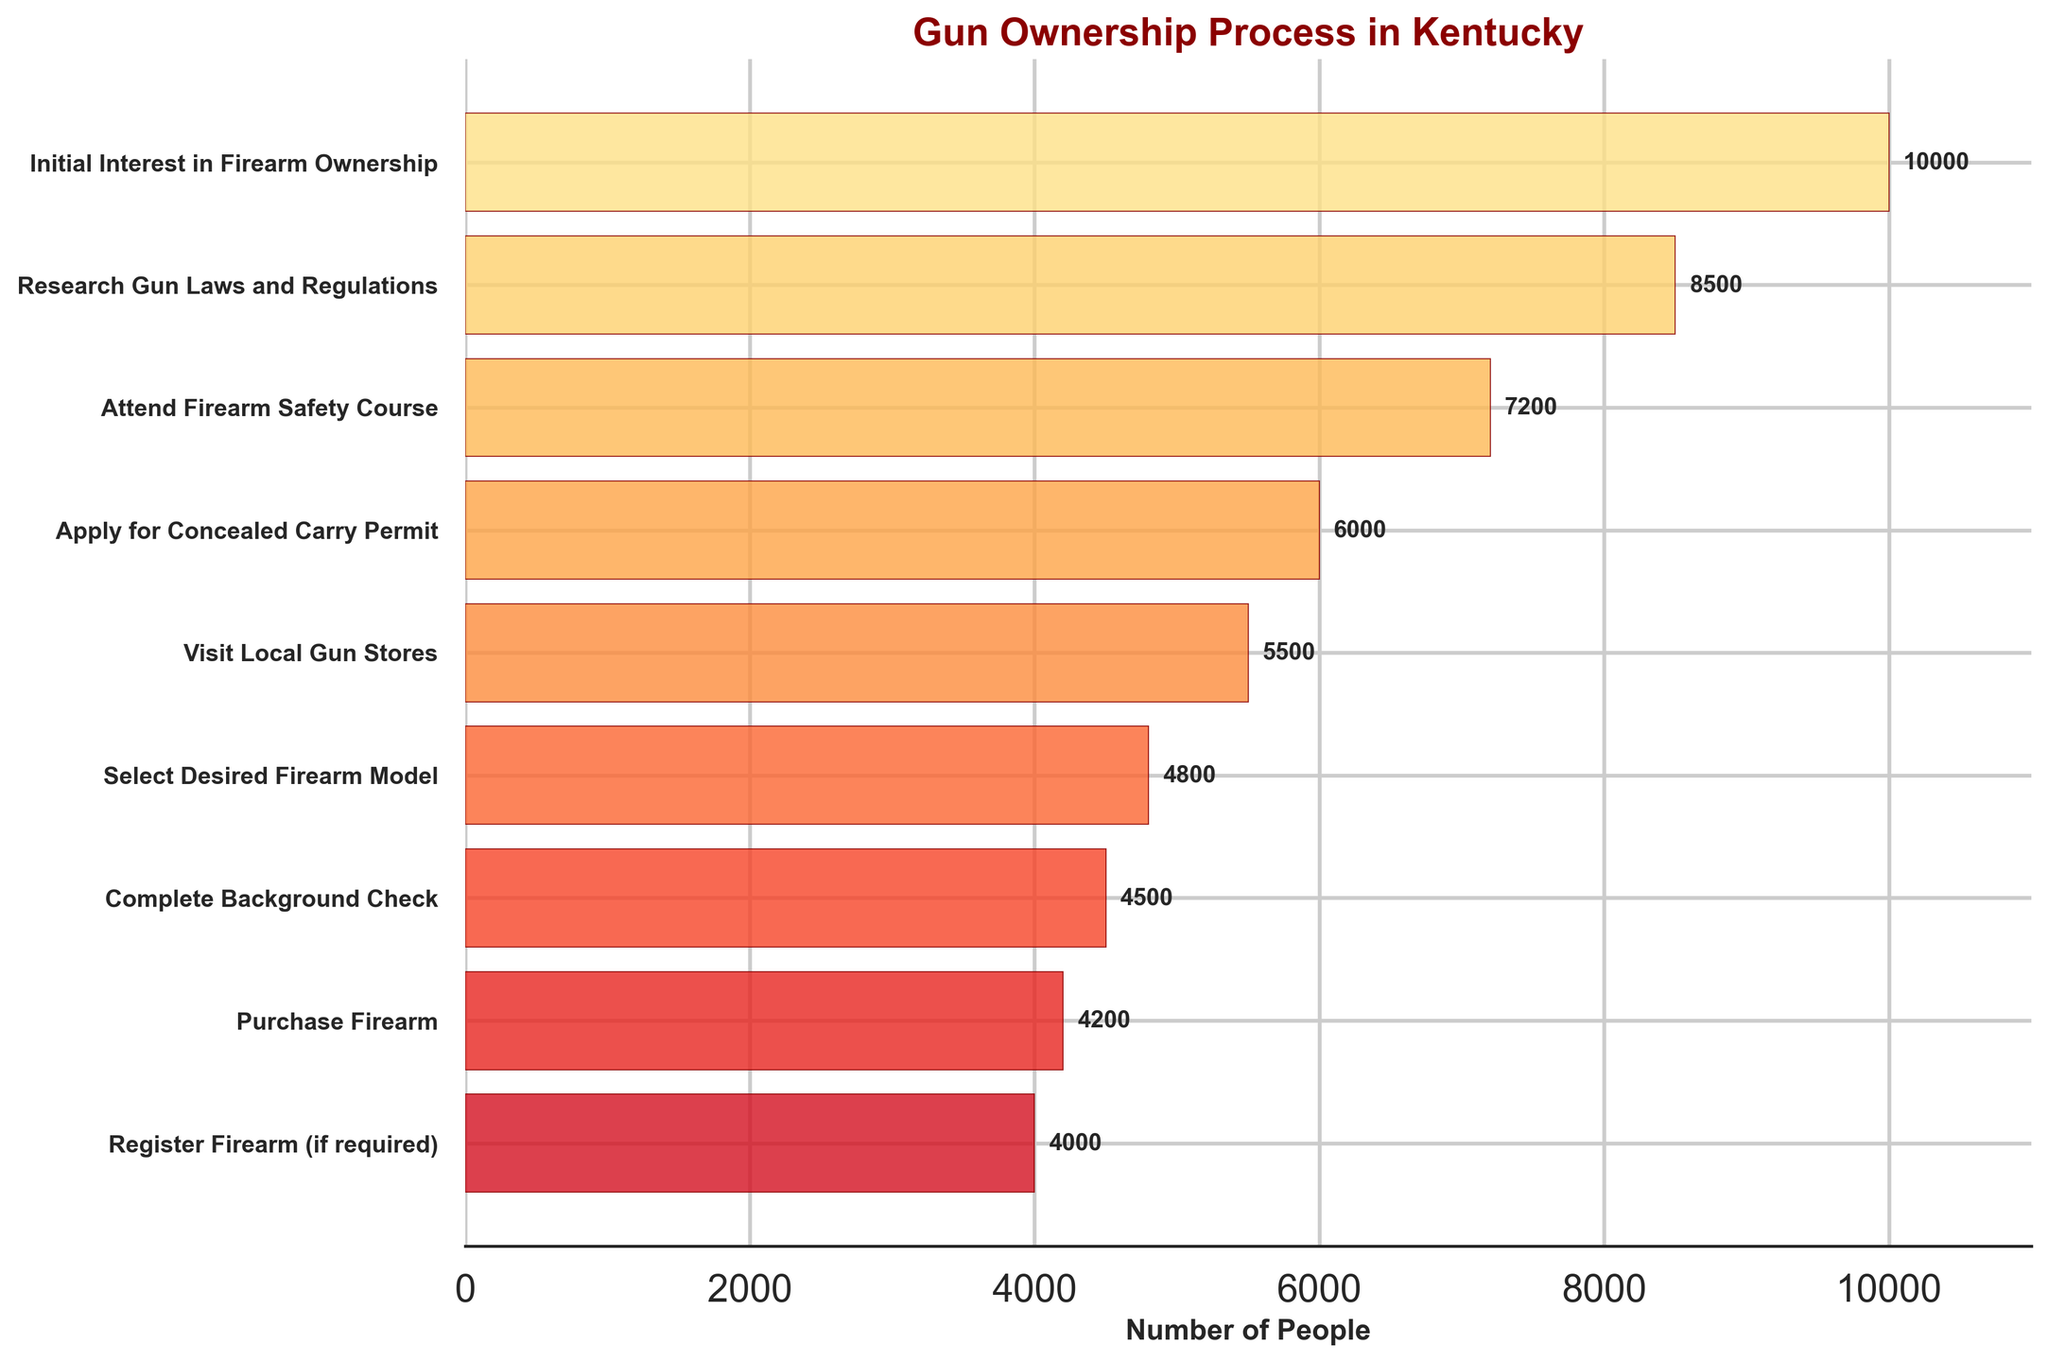What's the title of the figure? The title is usually displayed at the top of the figure and provides a summary of what the chart is about. In this case, it is written in a larger and boldened font.
Answer: Gun Ownership Process in Kentucky What’s the largest drop in the number of people between any two consecutive stages? To find the largest drop, calculate the difference in the number of people between each consecutive stage and identify the maximum difference. The differences are as follows: 
Initial Interest to Research Gun Laws: 10000 - 8500 = 1500,
Research Gun Laws to Attend Safety Course: 8500 - 7200 = 1300,
Safety Course to Apply for Permit: 7200 - 6000 = 1200,
Apply for Permit to Visit Local Gun Stores: 6000 - 5500 = 500,
Visit Gun Stores to Select Firearm: 5500 - 4800 = 700,
Select Firearm to Background Check: 4800 - 4500 = 300,
Background Check to Purchase Firearm: 4500 - 4200 = 300,
Purchase Firearm to Register Firearm: 4200 - 4000 = 200.
The largest drop is from Initial Interest to Research Gun Laws, which is 1500.
Answer: 1500 How many people complete the background check? The number is displayed next to the "Complete Background Check" stage in the figure.
Answer: 4500 Which stage has the highest number of people? The stage with the highest number of people is the first stage, "Initial Interest in Firearm Ownership," as inferred from its position at the top and its longer bar length in the funnel chart.
Answer: Initial Interest in Firearm Ownership What percentage of people who attended the firearm safety course actually purchased a firearm? Calculate the percentage by dividing the number of people who purchased a firearm by the number of people who attended the firearm safety course and then multiplying by 100.
Number who purchased firearm = 4200,
Number who attended safety course = 7200,
Percentage = (4200 / 7200) * 100 = 58.33%.
Answer: 58.33% How many stages show more than 5000 people? Identify the stages and count how many numbers are greater than 5000. The stages are: Initial Interest (10000), Research Gun Laws (8500), Attend Safety Course (7200), Apply for Permit (6000), Visit Local Gun Stores (5500). So, there are 5 such stages.
Answer: 5 Which transition has the smallest drop in the number of people? Calculate the differences between each transition stage:
Initial Interest to Research Gun Laws: 1500,
Research Gun Laws to Attend Safety Course: 1300,
Safety Course to Apply for Permit: 1200,
Apply for Permit to Visit Local Gun Stores: 500,
Visit Gun Stores to Select Firearm: 700,
Select Firearm to Background Check: 300,
Background Check to Purchase Firearm: 300
Purchase Firearm to Register Firearm: 200.
The smallest drop is from Purchase Firearm to Register Firearm, 200 people.
Answer: Purchase Firearm to Register Firearm How many stages are represented in the figure? Count the number of distinct stages listed on the y-axis, from the top to the bottom.
Answer: 9 